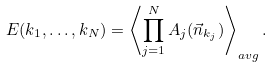Convert formula to latex. <formula><loc_0><loc_0><loc_500><loc_500>E ( { k _ { 1 } } , \dots , { k _ { N } } ) = \left \langle \prod _ { j = 1 } ^ { N } A _ { j } ( \vec { n } _ { k _ { j } } ) \right \rangle _ { a v g } .</formula> 